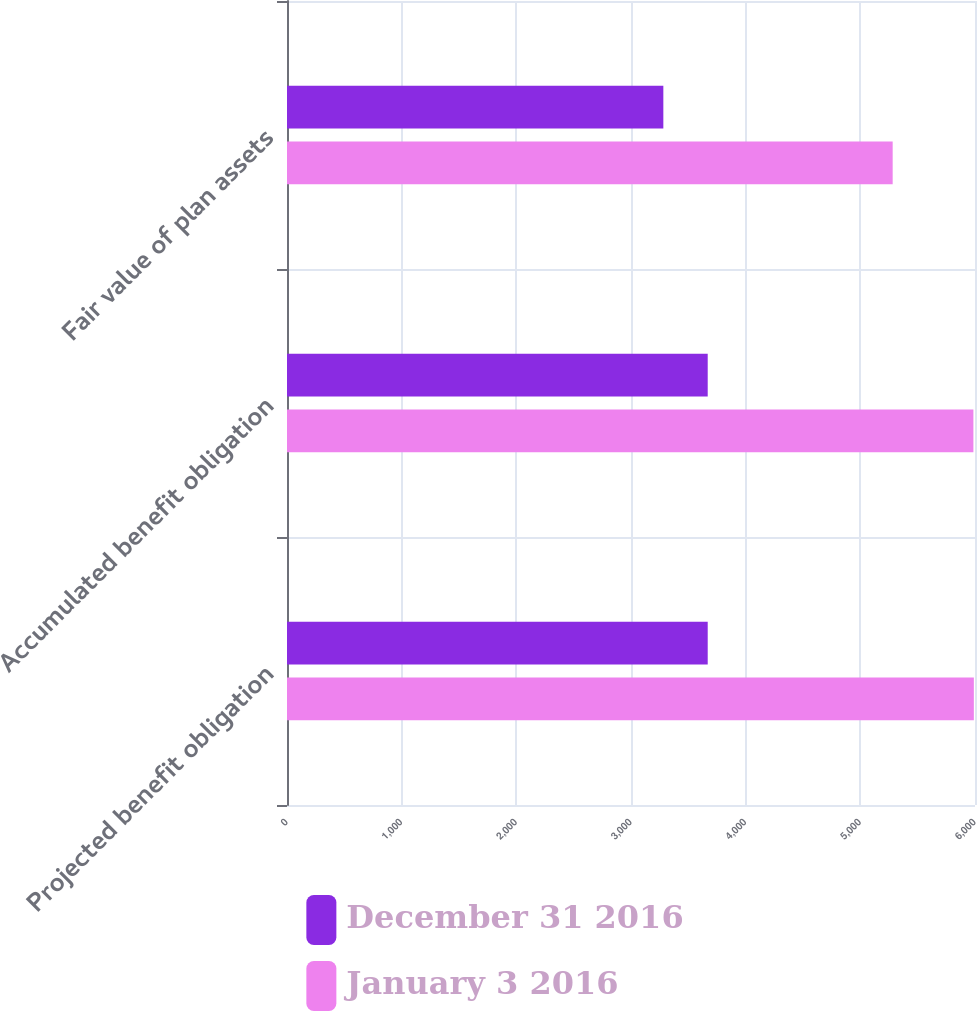<chart> <loc_0><loc_0><loc_500><loc_500><stacked_bar_chart><ecel><fcel>Projected benefit obligation<fcel>Accumulated benefit obligation<fcel>Fair value of plan assets<nl><fcel>December 31 2016<fcel>3669<fcel>3669<fcel>3282<nl><fcel>January 3 2016<fcel>5990<fcel>5986<fcel>5282<nl></chart> 